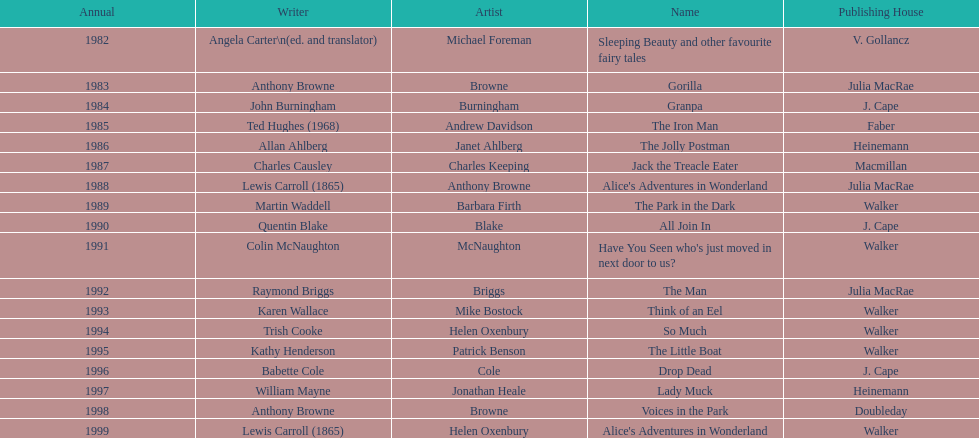Which illustrator was responsible for the last award winner? Helen Oxenbury. 